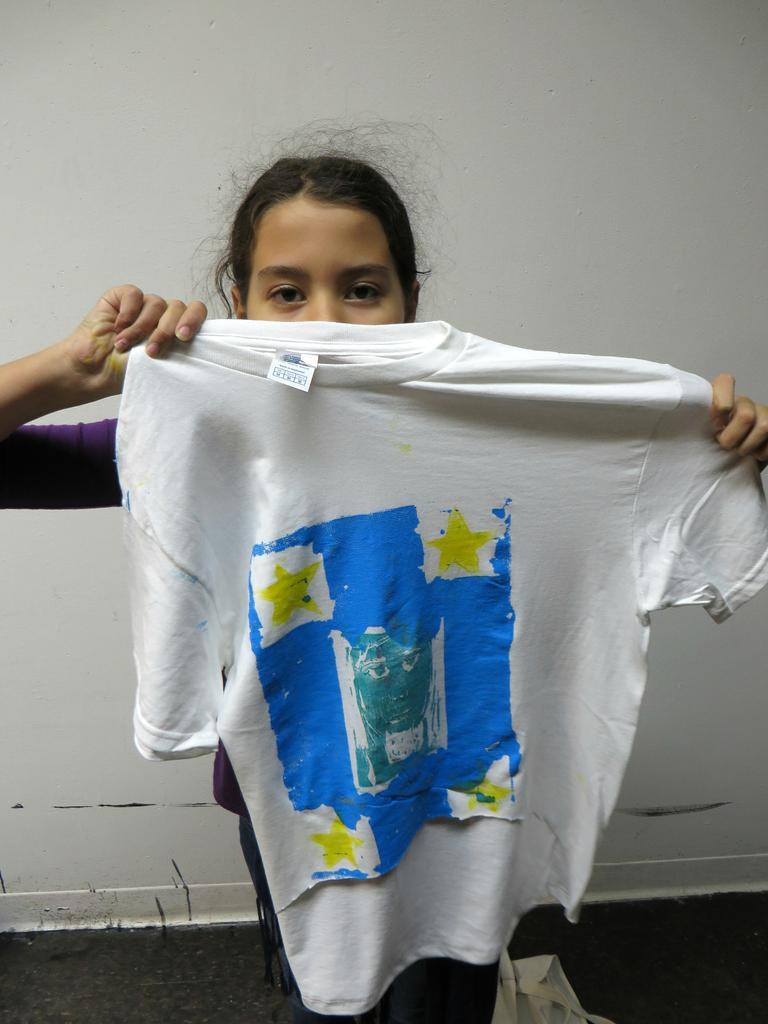Please provide a concise description of this image. This picture is taken inside the room. In this image, in the middle, we can see a girl standing and holding a t shirt in her hand. In the background, we can see a wall. 